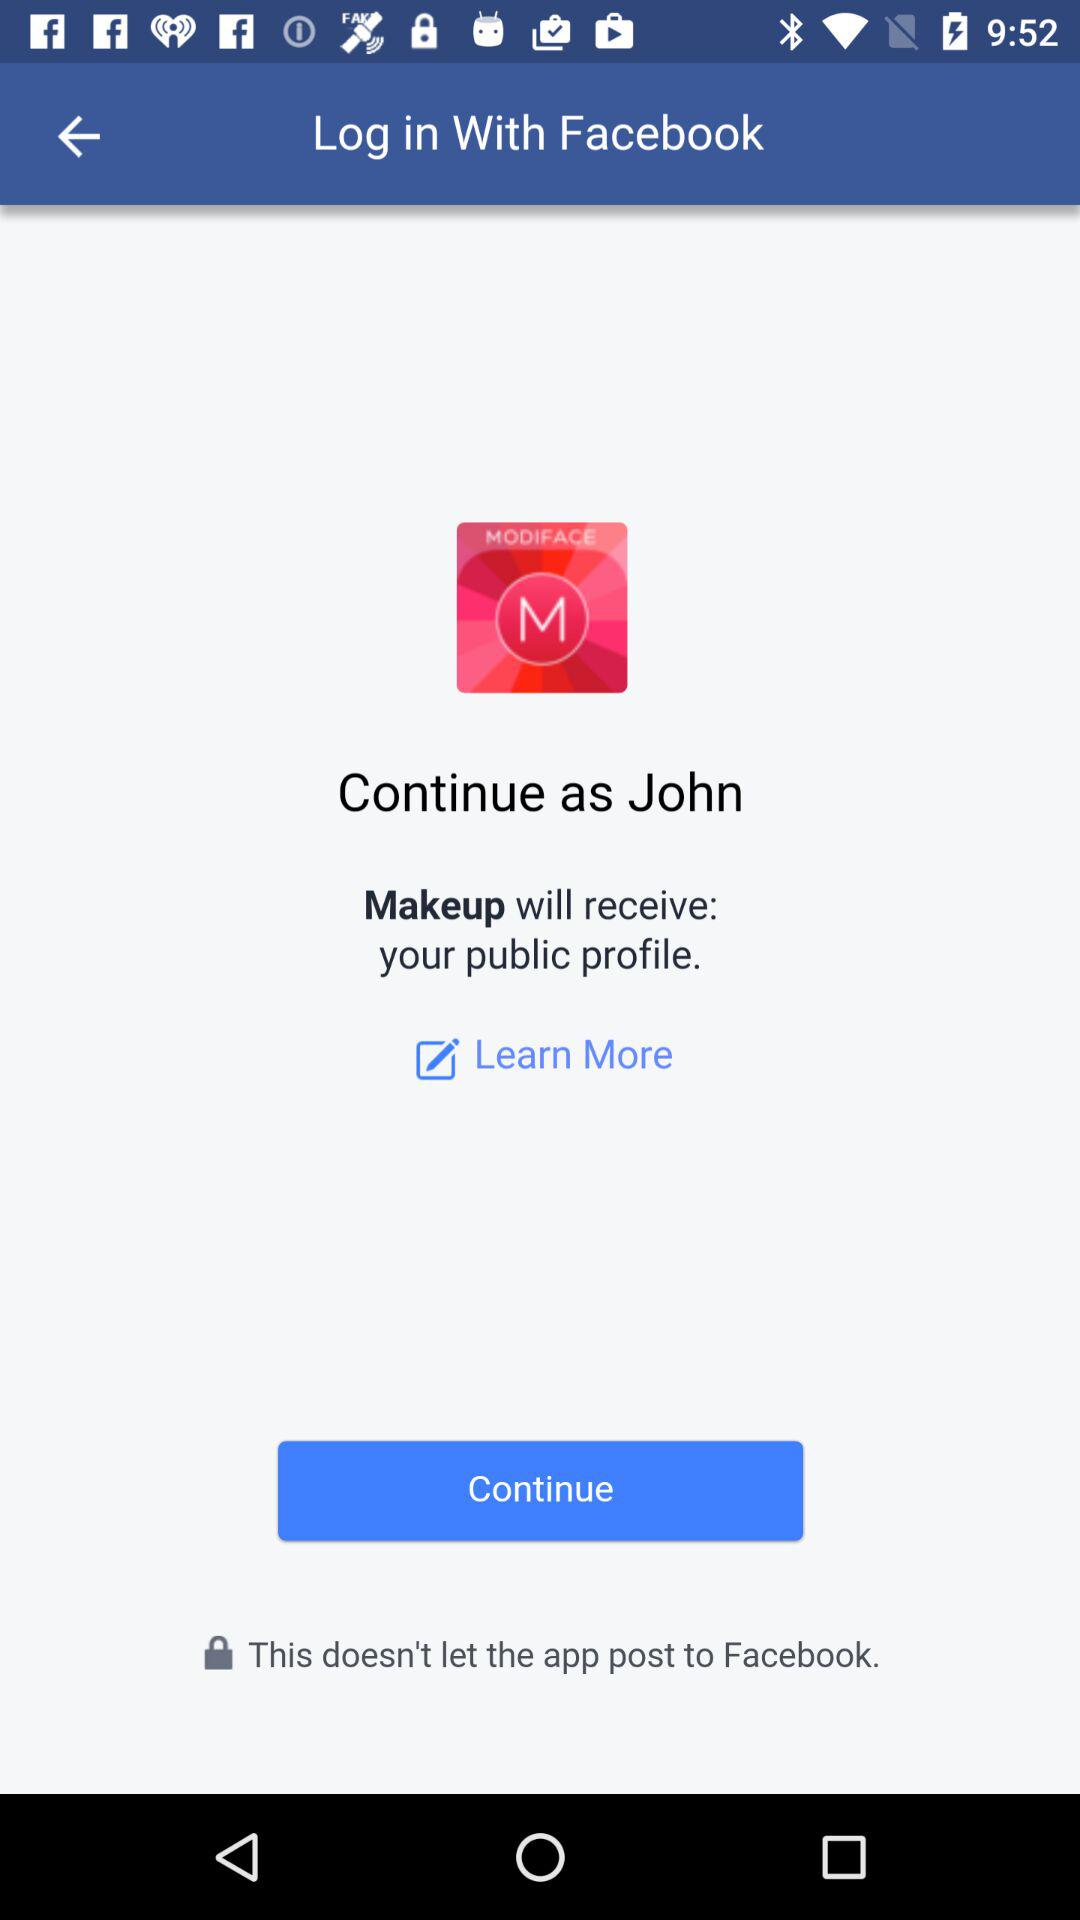What application is asking for permissions? The application is "Makeup". 